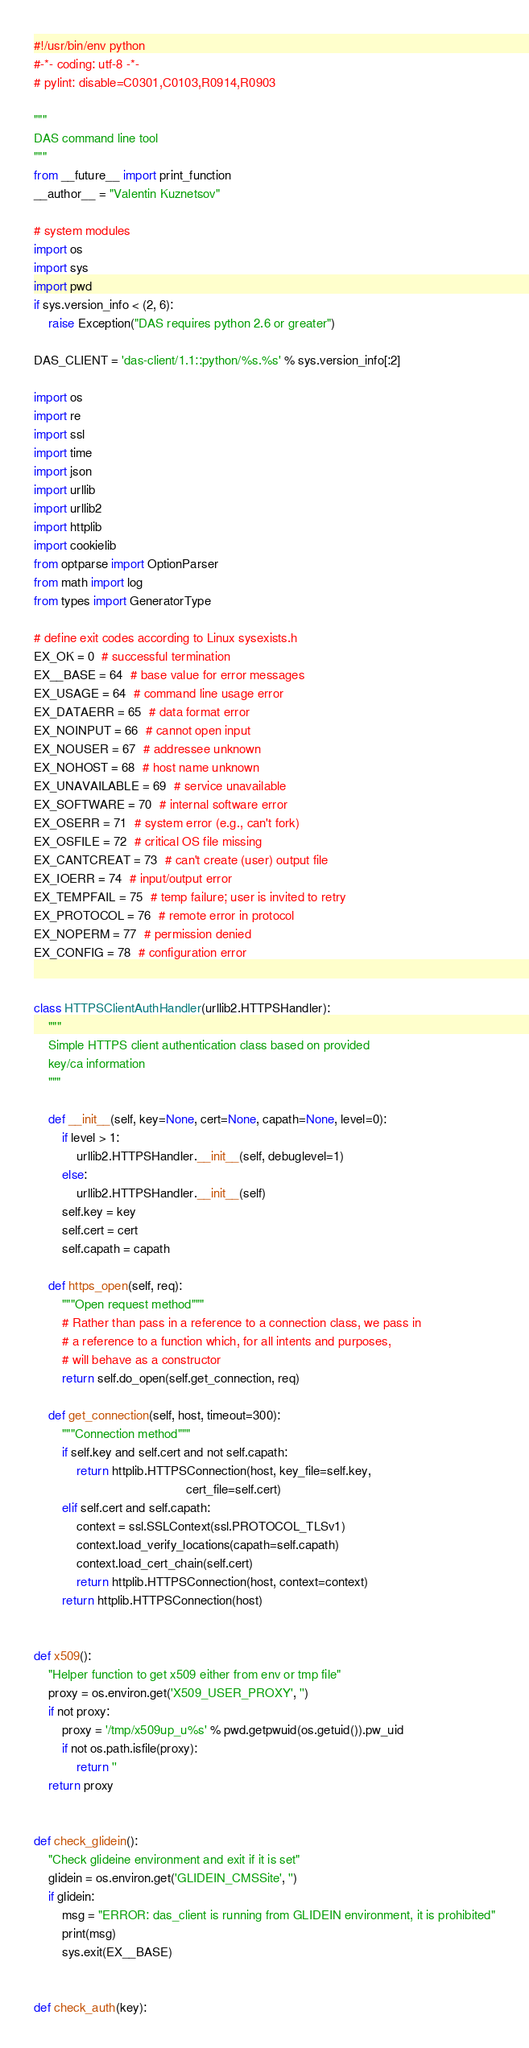<code> <loc_0><loc_0><loc_500><loc_500><_Python_>#!/usr/bin/env python
#-*- coding: utf-8 -*-
# pylint: disable=C0301,C0103,R0914,R0903

"""
DAS command line tool
"""
from __future__ import print_function
__author__ = "Valentin Kuznetsov"

# system modules
import os
import sys
import pwd
if sys.version_info < (2, 6):
    raise Exception("DAS requires python 2.6 or greater")

DAS_CLIENT = 'das-client/1.1::python/%s.%s' % sys.version_info[:2]

import os
import re
import ssl
import time
import json
import urllib
import urllib2
import httplib
import cookielib
from optparse import OptionParser
from math import log
from types import GeneratorType

# define exit codes according to Linux sysexists.h
EX_OK = 0  # successful termination
EX__BASE = 64  # base value for error messages
EX_USAGE = 64  # command line usage error
EX_DATAERR = 65  # data format error
EX_NOINPUT = 66  # cannot open input
EX_NOUSER = 67  # addressee unknown
EX_NOHOST = 68  # host name unknown
EX_UNAVAILABLE = 69  # service unavailable
EX_SOFTWARE = 70  # internal software error
EX_OSERR = 71  # system error (e.g., can't fork)
EX_OSFILE = 72  # critical OS file missing
EX_CANTCREAT = 73  # can't create (user) output file
EX_IOERR = 74  # input/output error
EX_TEMPFAIL = 75  # temp failure; user is invited to retry
EX_PROTOCOL = 76  # remote error in protocol
EX_NOPERM = 77  # permission denied
EX_CONFIG = 78  # configuration error


class HTTPSClientAuthHandler(urllib2.HTTPSHandler):
    """
    Simple HTTPS client authentication class based on provided
    key/ca information
    """

    def __init__(self, key=None, cert=None, capath=None, level=0):
        if level > 1:
            urllib2.HTTPSHandler.__init__(self, debuglevel=1)
        else:
            urllib2.HTTPSHandler.__init__(self)
        self.key = key
        self.cert = cert
        self.capath = capath

    def https_open(self, req):
        """Open request method"""
        # Rather than pass in a reference to a connection class, we pass in
        # a reference to a function which, for all intents and purposes,
        # will behave as a constructor
        return self.do_open(self.get_connection, req)

    def get_connection(self, host, timeout=300):
        """Connection method"""
        if self.key and self.cert and not self.capath:
            return httplib.HTTPSConnection(host, key_file=self.key,
                                           cert_file=self.cert)
        elif self.cert and self.capath:
            context = ssl.SSLContext(ssl.PROTOCOL_TLSv1)
            context.load_verify_locations(capath=self.capath)
            context.load_cert_chain(self.cert)
            return httplib.HTTPSConnection(host, context=context)
        return httplib.HTTPSConnection(host)


def x509():
    "Helper function to get x509 either from env or tmp file"
    proxy = os.environ.get('X509_USER_PROXY', '')
    if not proxy:
        proxy = '/tmp/x509up_u%s' % pwd.getpwuid(os.getuid()).pw_uid
        if not os.path.isfile(proxy):
            return ''
    return proxy


def check_glidein():
    "Check glideine environment and exit if it is set"
    glidein = os.environ.get('GLIDEIN_CMSSite', '')
    if glidein:
        msg = "ERROR: das_client is running from GLIDEIN environment, it is prohibited"
        print(msg)
        sys.exit(EX__BASE)


def check_auth(key):</code> 